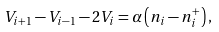Convert formula to latex. <formula><loc_0><loc_0><loc_500><loc_500>V _ { i + 1 } - V _ { i - 1 } - 2 V _ { i } = \alpha \left ( n _ { i } - n ^ { + } _ { i } \right ) ,</formula> 